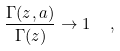Convert formula to latex. <formula><loc_0><loc_0><loc_500><loc_500>\frac { \Gamma ( z , a ) } { \Gamma ( z ) } \to 1 \ \ ,</formula> 